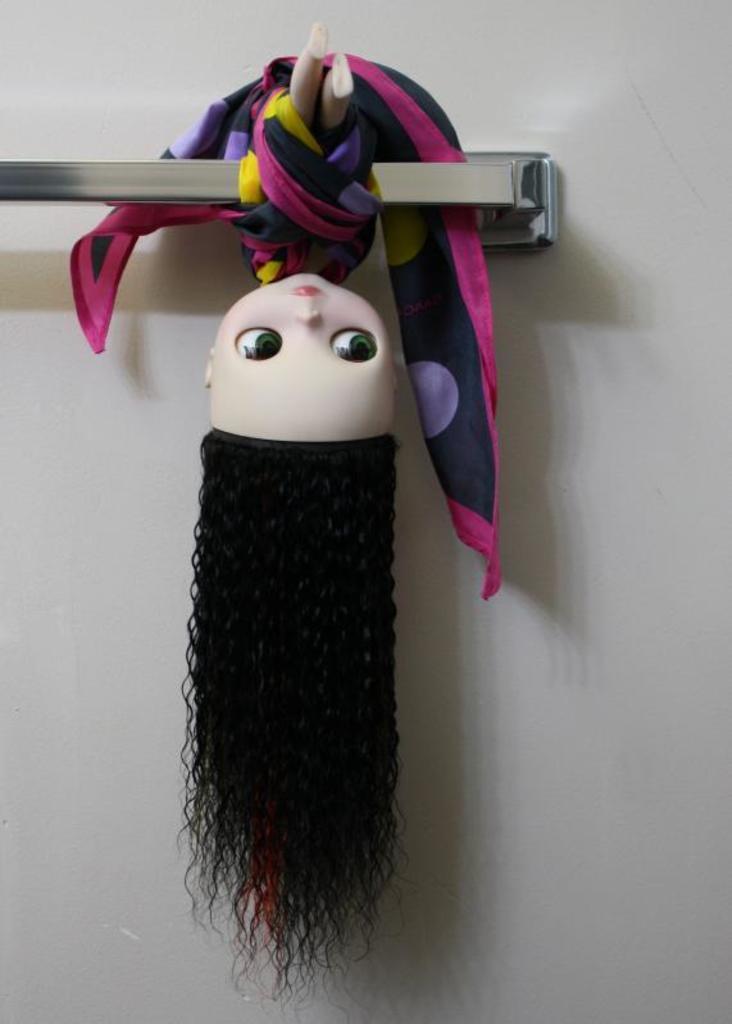In one or two sentences, can you explain what this image depicts? In this picture there is a doll which is hanged from a rod in the center of the image. 